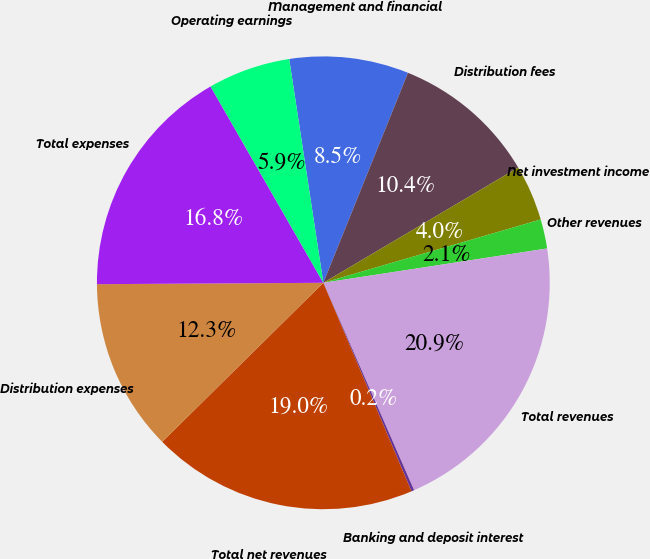Convert chart to OTSL. <chart><loc_0><loc_0><loc_500><loc_500><pie_chart><fcel>Management and financial<fcel>Distribution fees<fcel>Net investment income<fcel>Other revenues<fcel>Total revenues<fcel>Banking and deposit interest<fcel>Total net revenues<fcel>Distribution expenses<fcel>Total expenses<fcel>Operating earnings<nl><fcel>8.51%<fcel>10.4%<fcel>3.99%<fcel>2.09%<fcel>20.86%<fcel>0.2%<fcel>18.97%<fcel>12.3%<fcel>16.8%<fcel>5.89%<nl></chart> 